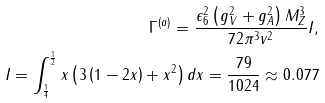<formula> <loc_0><loc_0><loc_500><loc_500>\Gamma ^ { ( a ) } = \frac { \epsilon _ { 6 } ^ { 2 } \left ( g _ { V } ^ { 2 } + g _ { A } ^ { 2 } \right ) M _ { Z } ^ { 3 } } { 7 2 \pi ^ { 3 } v ^ { 2 } } I , \\ I = \int _ { \frac { 1 } { 4 } } ^ { \frac { 1 } { 2 } } x \left ( 3 \left ( 1 - 2 x \right ) + x ^ { 2 } \right ) d x = \frac { 7 9 } { 1 0 2 4 } \approx 0 . 0 7 7</formula> 